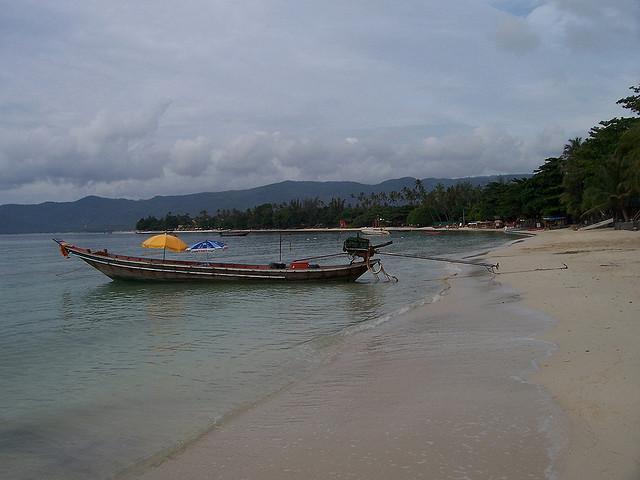How many umbrellas are on the boat?
Give a very brief answer. 2. How many cares are to the left of the bike rider?
Give a very brief answer. 0. 